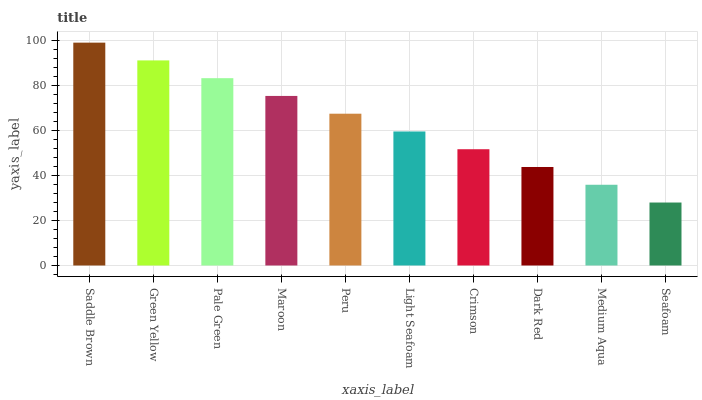Is Seafoam the minimum?
Answer yes or no. Yes. Is Saddle Brown the maximum?
Answer yes or no. Yes. Is Green Yellow the minimum?
Answer yes or no. No. Is Green Yellow the maximum?
Answer yes or no. No. Is Saddle Brown greater than Green Yellow?
Answer yes or no. Yes. Is Green Yellow less than Saddle Brown?
Answer yes or no. Yes. Is Green Yellow greater than Saddle Brown?
Answer yes or no. No. Is Saddle Brown less than Green Yellow?
Answer yes or no. No. Is Peru the high median?
Answer yes or no. Yes. Is Light Seafoam the low median?
Answer yes or no. Yes. Is Pale Green the high median?
Answer yes or no. No. Is Seafoam the low median?
Answer yes or no. No. 